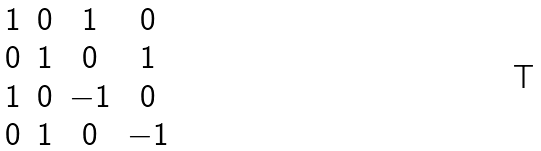<formula> <loc_0><loc_0><loc_500><loc_500>\begin{matrix} 1 & 0 & 1 & 0 \\ 0 & 1 & 0 & 1 \\ 1 & 0 & - 1 & 0 \\ 0 & 1 & 0 & - 1 \end{matrix}</formula> 